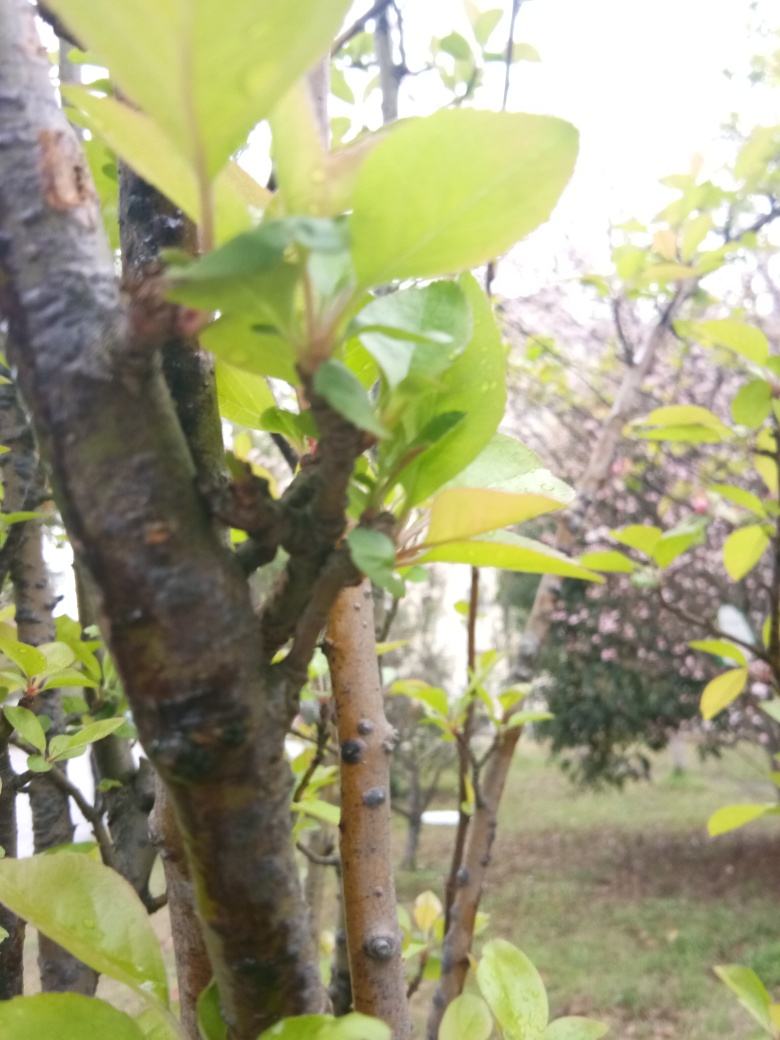What time of day does this image seem to represent? The soft, diffused lighting in the image suggests it may have been taken during the early morning or late afternoon, when the sun is not at its peak brightness. What can you tell me about the season or climate? The presence of moisture on the leaves and the overall verdant appearance of the vegetation might indicate that it's either spring or fall in a temperate climate, a time when rainfall is common and plants are thriving or undergoing growth spurts. 